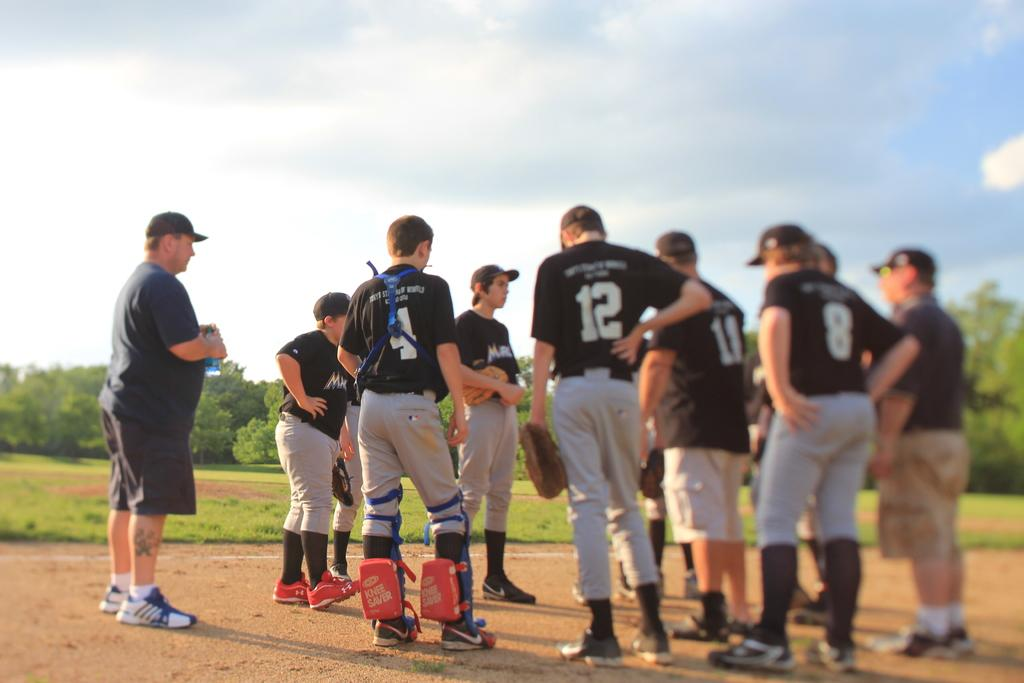<image>
Render a clear and concise summary of the photo. Man wearing a number 12 jersey standing in a huddle. 